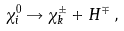Convert formula to latex. <formula><loc_0><loc_0><loc_500><loc_500>\chi ^ { 0 } _ { i } \rightarrow \chi ^ { \pm } _ { k } + H ^ { \mp } \, ,</formula> 